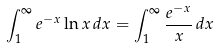<formula> <loc_0><loc_0><loc_500><loc_500>\int _ { 1 } ^ { \infty } e ^ { - x } \ln x \, d x = \int _ { 1 } ^ { \infty } \frac { e ^ { - x } } { x } \, d x</formula> 